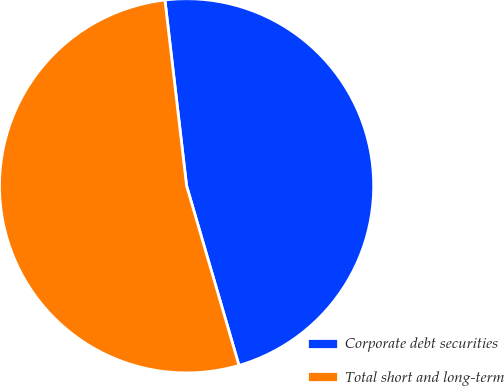Convert chart to OTSL. <chart><loc_0><loc_0><loc_500><loc_500><pie_chart><fcel>Corporate debt securities<fcel>Total short and long-term<nl><fcel>47.33%<fcel>52.67%<nl></chart> 